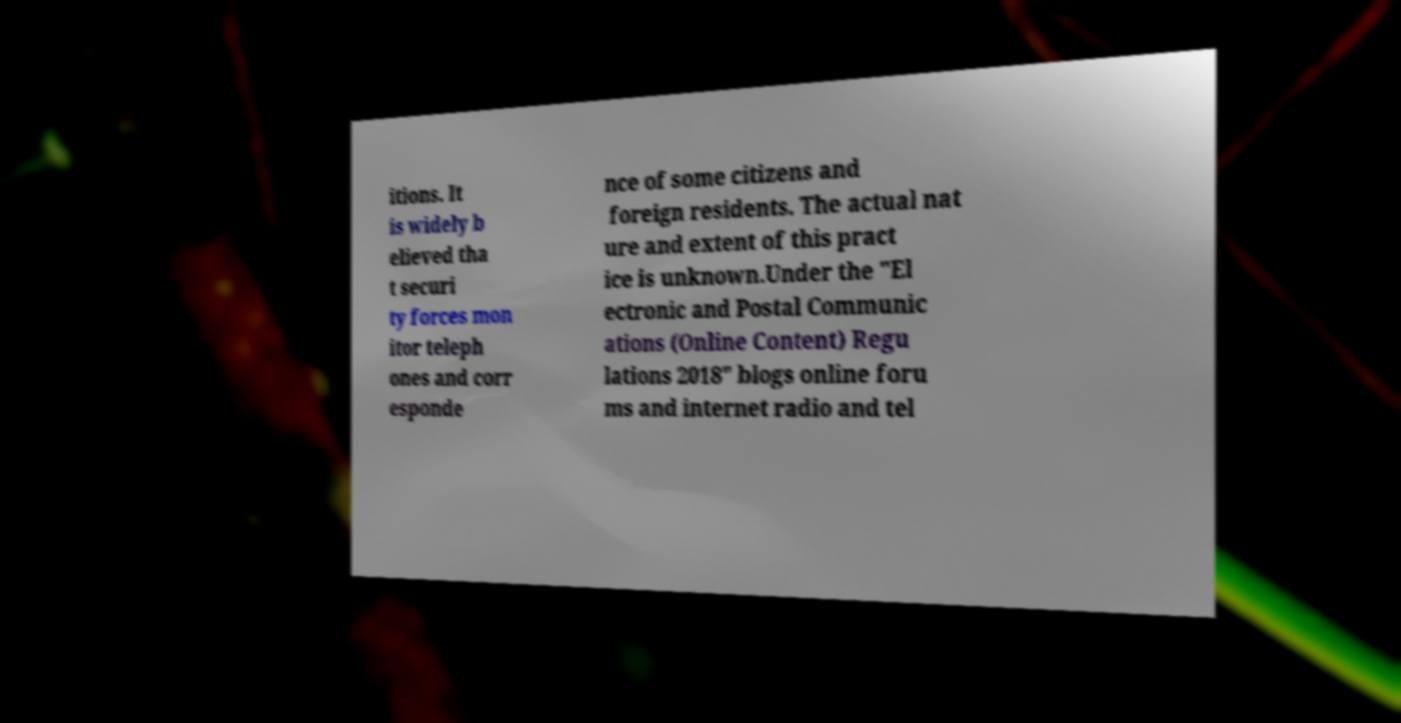Could you extract and type out the text from this image? itions. It is widely b elieved tha t securi ty forces mon itor teleph ones and corr esponde nce of some citizens and foreign residents. The actual nat ure and extent of this pract ice is unknown.Under the "El ectronic and Postal Communic ations (Online Content) Regu lations 2018" blogs online foru ms and internet radio and tel 